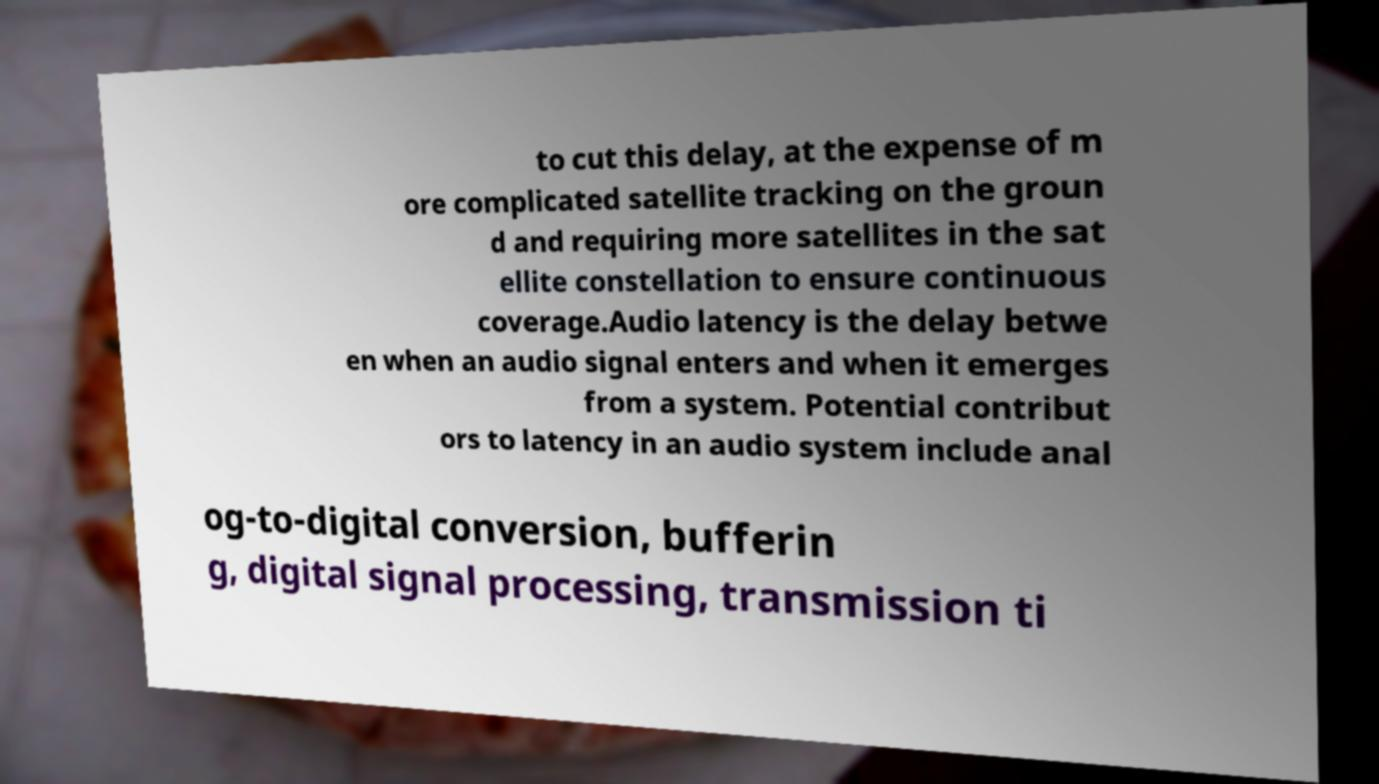Please read and relay the text visible in this image. What does it say? to cut this delay, at the expense of m ore complicated satellite tracking on the groun d and requiring more satellites in the sat ellite constellation to ensure continuous coverage.Audio latency is the delay betwe en when an audio signal enters and when it emerges from a system. Potential contribut ors to latency in an audio system include anal og-to-digital conversion, bufferin g, digital signal processing, transmission ti 